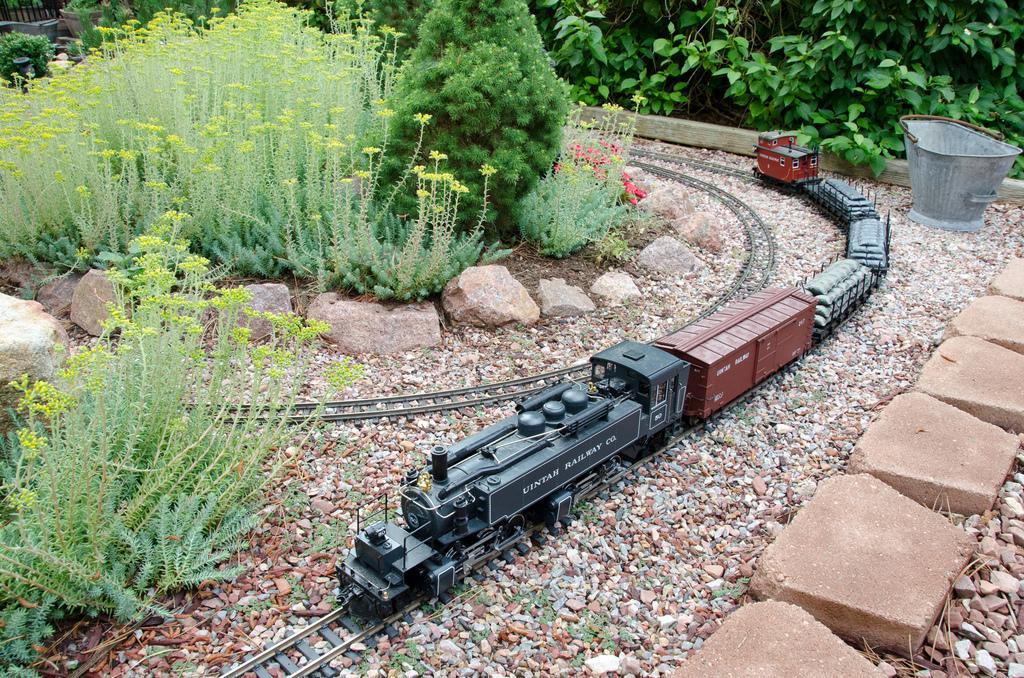Describe this image in one or two sentences. In the center of the image there is a toy of a train. At the bottom of the image there are stones, bricks. On the left side of the image there are plants. On the right side of the image there is a bucket. 